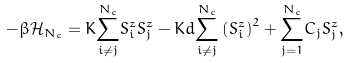<formula> <loc_0><loc_0><loc_500><loc_500>- \beta \mathcal { H } _ { N _ { c } } = K \overset { N _ { c } } { \underset { i \neq j } { \sum } } S _ { i } ^ { z } S _ { j } ^ { z } - K d \overset { N _ { c } } { \underset { i \neq j } { \sum } } \left ( S _ { i } ^ { z } \right ) ^ { 2 } + \overset { N _ { c } } { \underset { j = 1 } { \sum } } C _ { j } S _ { j } ^ { z } ,</formula> 